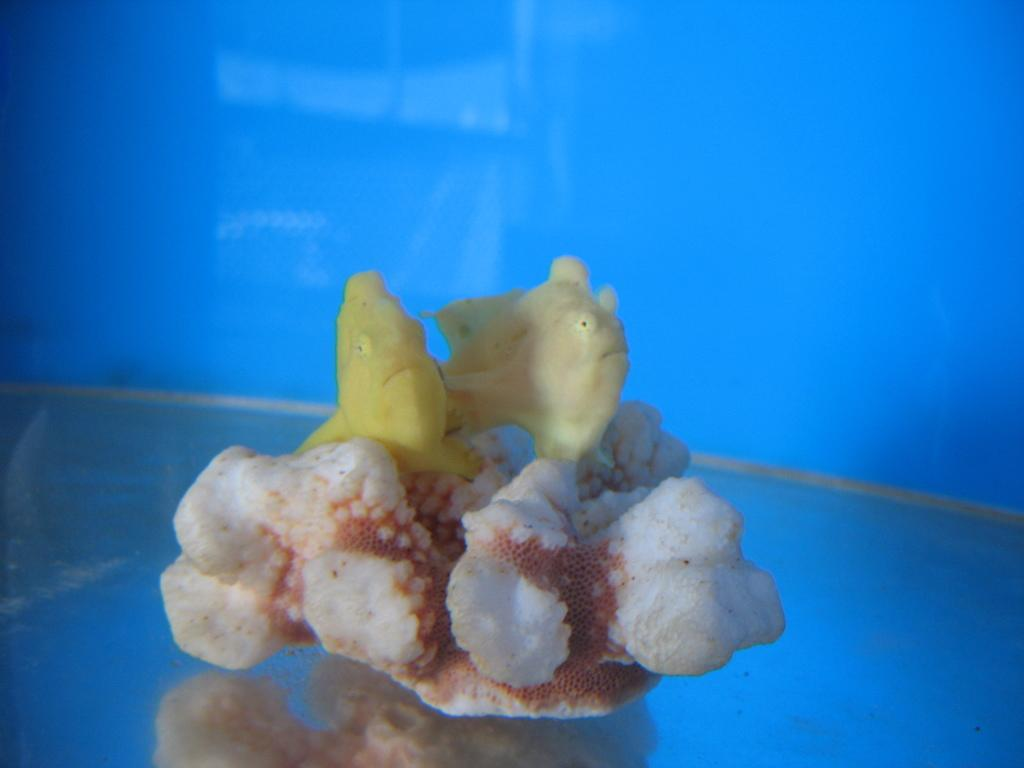What is the main object in the center of the image? There is a white and brown color object in the center of the image. What is depicted on the object? There are two fish on the object, and they are yellow in color. What color is the background of the image? The background of the image is blue. Where is the quince located in the image? There is no quince present in the image. Can you see a dock in the image? There is no dock present in the image. 